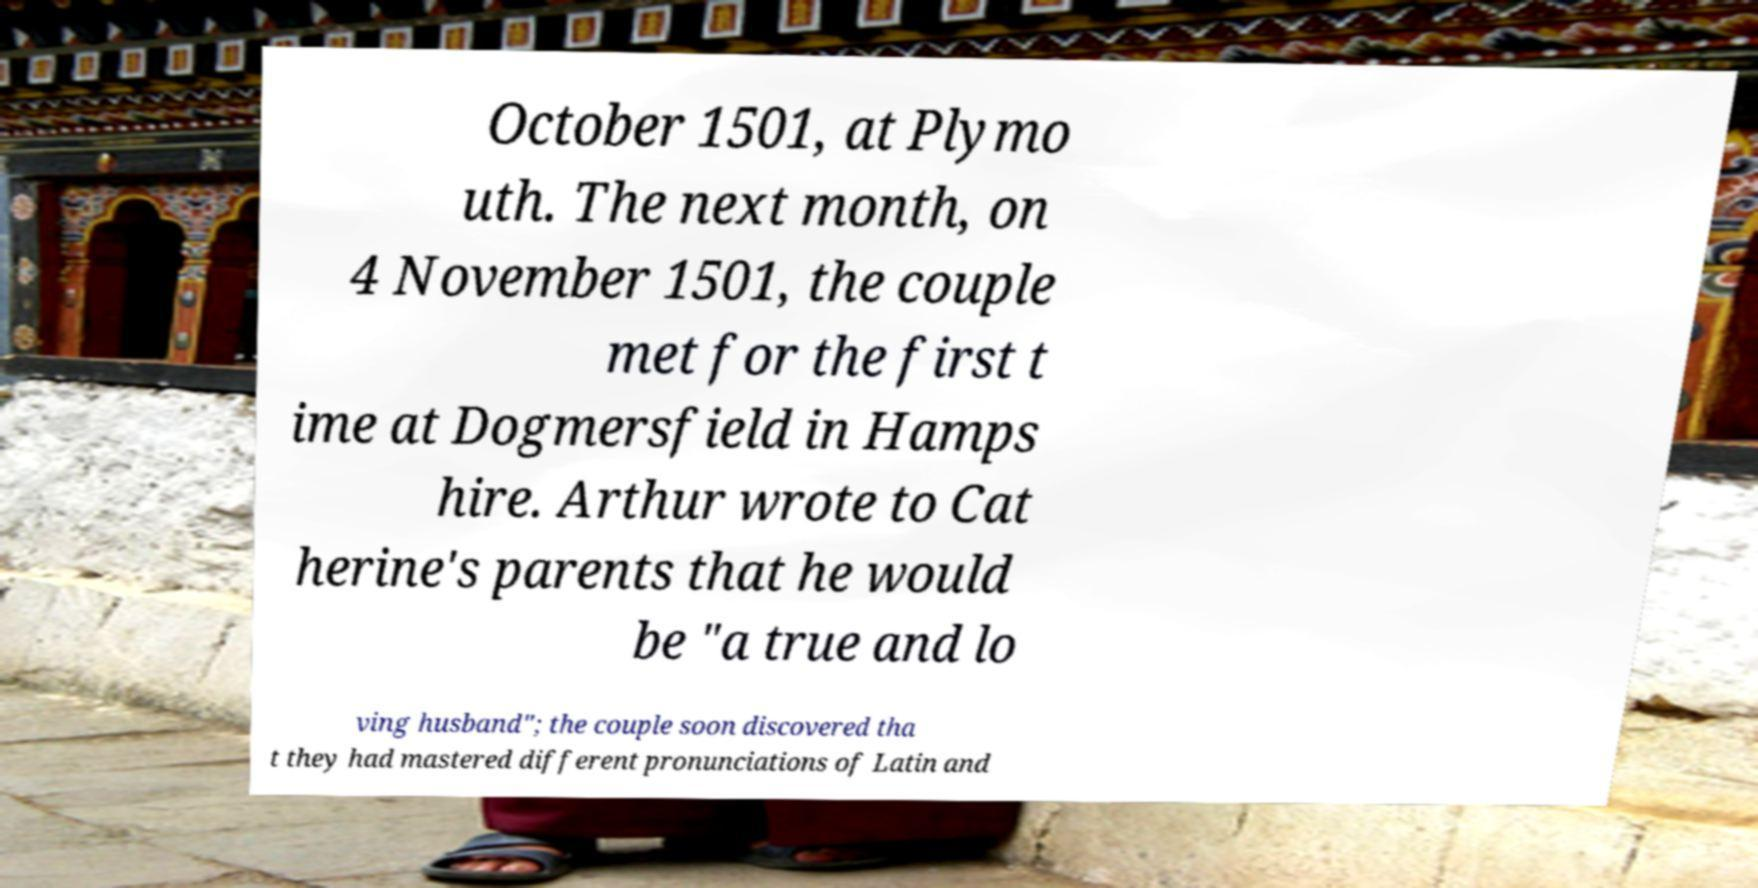Can you accurately transcribe the text from the provided image for me? October 1501, at Plymo uth. The next month, on 4 November 1501, the couple met for the first t ime at Dogmersfield in Hamps hire. Arthur wrote to Cat herine's parents that he would be "a true and lo ving husband"; the couple soon discovered tha t they had mastered different pronunciations of Latin and 